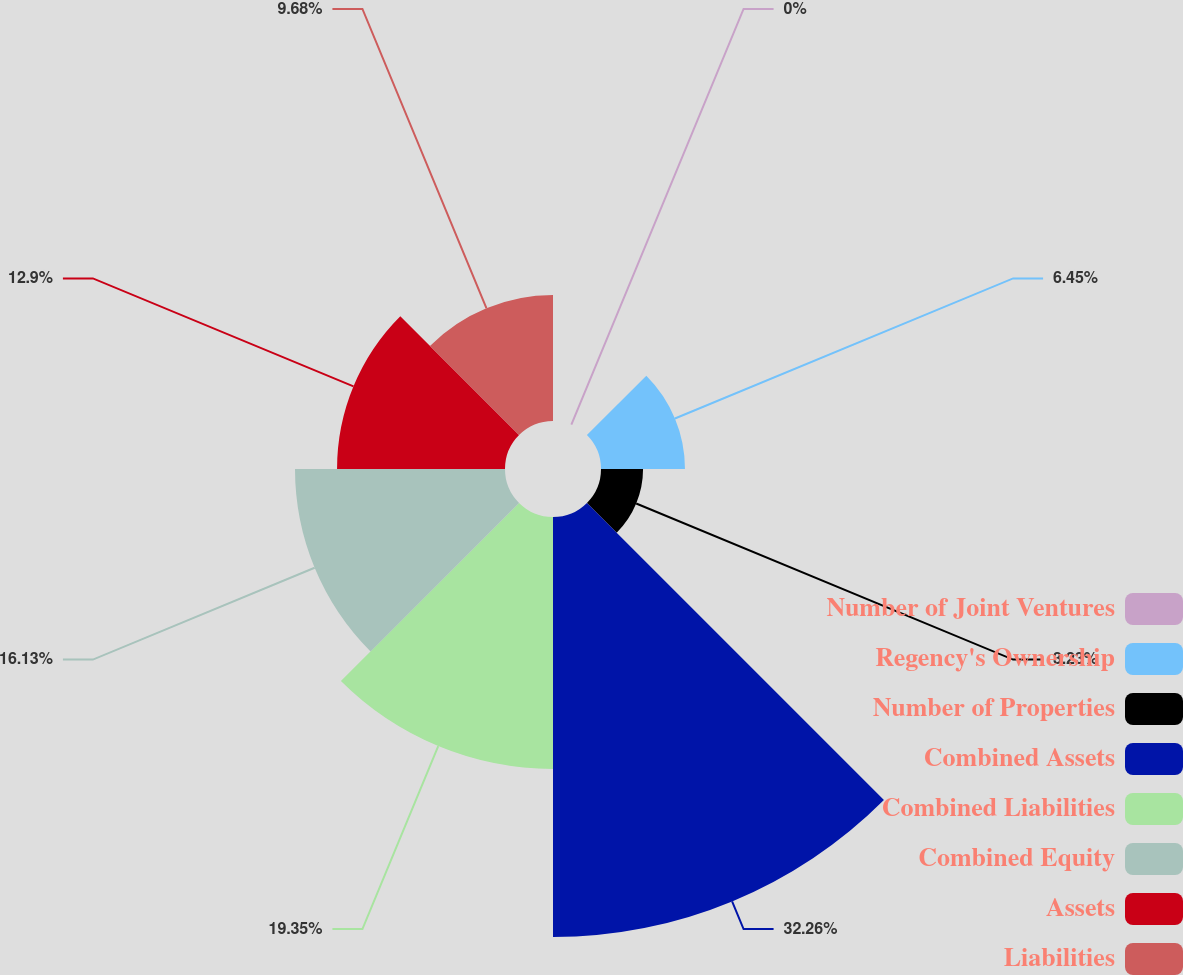Convert chart to OTSL. <chart><loc_0><loc_0><loc_500><loc_500><pie_chart><fcel>Number of Joint Ventures<fcel>Regency's Ownership<fcel>Number of Properties<fcel>Combined Assets<fcel>Combined Liabilities<fcel>Combined Equity<fcel>Assets<fcel>Liabilities<nl><fcel>0.0%<fcel>6.45%<fcel>3.23%<fcel>32.26%<fcel>19.35%<fcel>16.13%<fcel>12.9%<fcel>9.68%<nl></chart> 